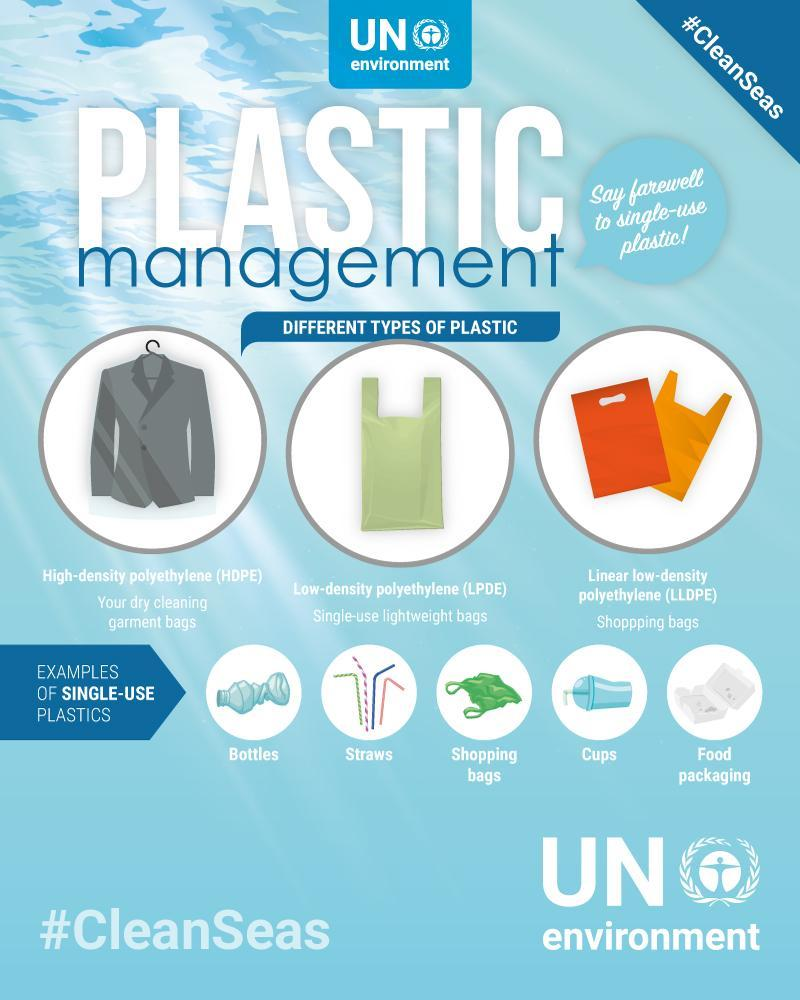What example has been given for HDPE
Answer the question with a short phrase. dry cleaning garment bags What is the colour of the single-use lightweight bags - yellow or green green Food packaging use what type of plastic single-use plastics 